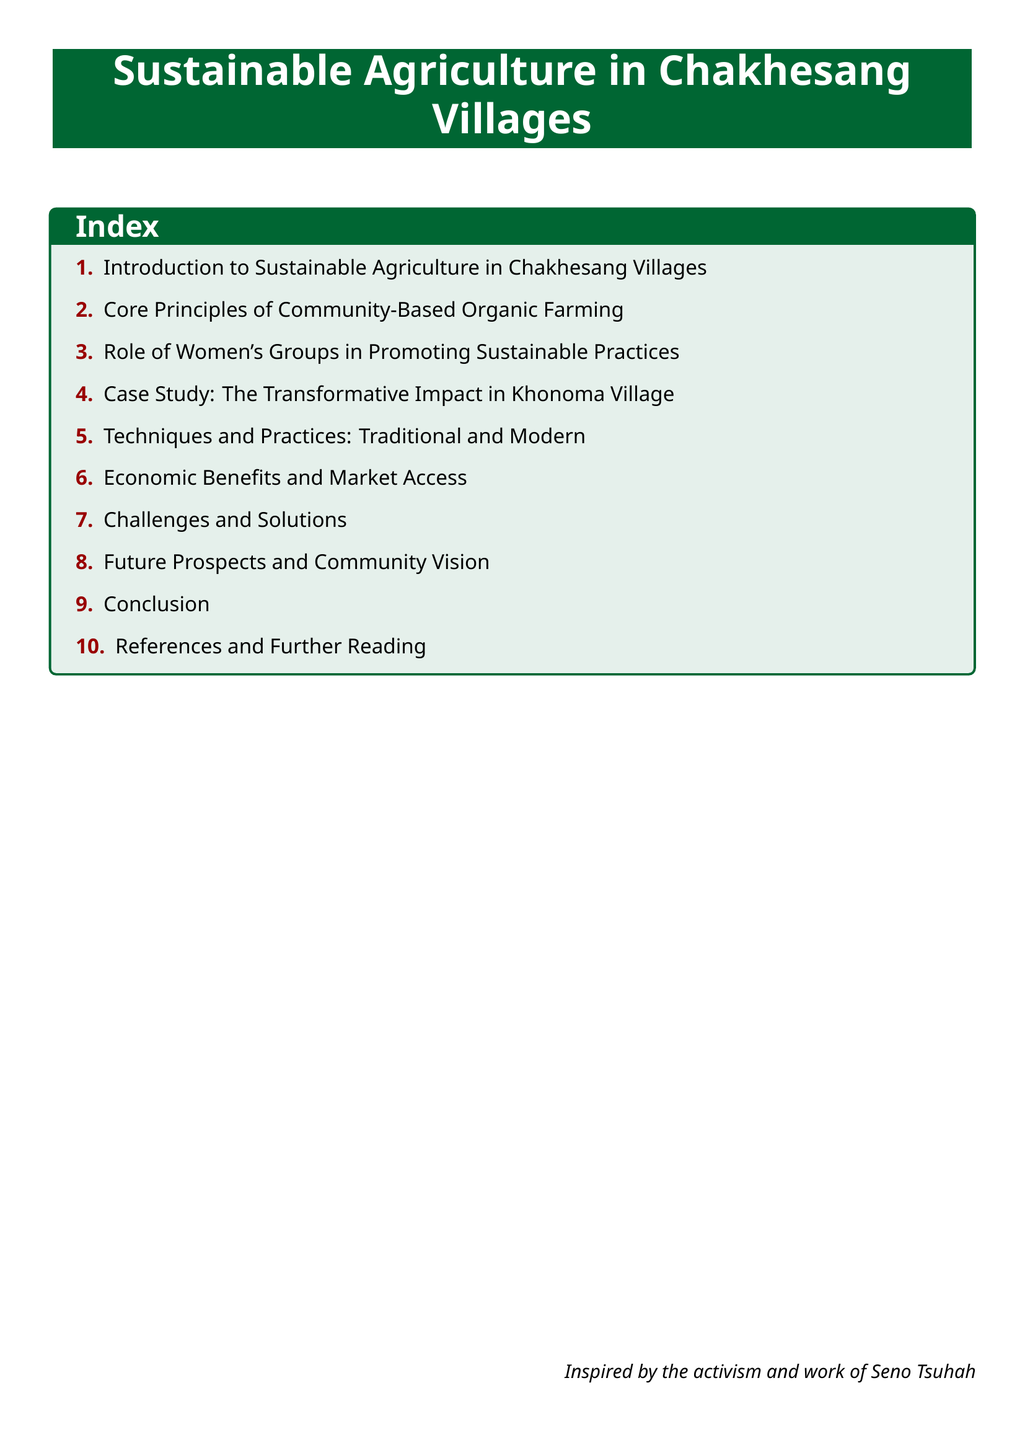What is the title of the document? The title of the document is the main heading found at the top of the rendered document, which summarizes the key topic covered.
Answer: Sustainable Agriculture in Chakhesang Villages How many sections are there in the index? The index lists all the sections from the document, where each item corresponds to a specific area of focus.
Answer: 10 Which village is highlighted in the case study? The case study section specifically mentions one village that serves as an example within the document.
Answer: Khonoma Village What color is used for the section titles? The section titles are formatted in a specific color that aligns with the theme of the document, indicating the style choice.
Answer: Nagagreen What is the focus of section three? This section emphasizes the involvement and contribution of a specific group within the community regarding sustainable practices.
Answer: Women's Groups What term describes the farming approach outlined in the core principles? The farming approach referred to in the core principles section highlights a specific, environmentally friendly method used in agricultural practices.
Answer: Community-Based Organic Farming Which two aspects are brushed upon in the section covering challenges? This section discusses the issues faced in the implementation of sustainable agriculture in Chakhesang villages along with potential resolutions.
Answer: Challenges and Solutions Who is mentioned as an inspiration in the document? The document concludes with an acknowledgment of an individual whose activism and work have influenced its themes and focus.
Answer: Seno Tsuhah 